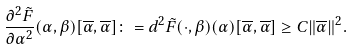<formula> <loc_0><loc_0><loc_500><loc_500>\frac { \partial ^ { 2 } \tilde { F } } { \partial \alpha ^ { 2 } } ( \alpha , \beta ) [ \overline { \alpha } , \overline { \alpha } ] \colon = d ^ { 2 } \tilde { F } ( \cdot , \beta ) ( \alpha ) [ \overline { \alpha } , \overline { \alpha } ] \geq C \| \overline { \alpha } \| ^ { 2 } .</formula> 